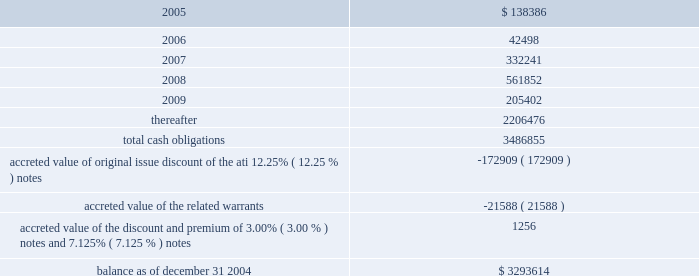American tower corporation and subsidiaries notes to consolidated financial statements 2014 ( continued ) other debt repurchases 2014during the year ended december 31 , 2004 , in addition to the redemptions discussed above , the company repurchased in privately negotiated transactions an aggregate of $ 309.7 million face amount of its ati 12.25% ( 12.25 % ) notes ( $ 179.4 million accreted value , net of $ 14.7 million fair value allocated to warrants ) for approximately $ 230.9 million in cash ; repurchased $ 112.1 million principal amount of its 93 20448% ( 20448 % ) notes for $ 118.9 million in cash ; and repurchased $ 73.7 million principal amount of its 5.0% ( 5.0 % ) notes for approximately $ 73.3 million in cash .
As a consequence of these transactions , the company recorded an aggregate charge of $ 66.4 million related to the write-off of deferred financing fees and amounts paid in excess of carrying value .
Such loss is reflected in loss on retirement of long-term obligations in the accompanying condensed consolidated statement of operations for the year ended december 31 , 2004 .
2.25% ( 2.25 % ) convertible notes repurchases 2014during the year ended december 31 , 2003 , the company repurchased an aggregate of $ 215.0 million accreted value ( $ 269.8 million face value ) of its 2.25% ( 2.25 % ) notes in exchange for an aggregate of 8415984 shares of class a common stock and $ 166.4 million in cash , including $ 84.2 million accreted value ( $ 104.9 million face amount ) of 2.25% ( 2.25 % ) notes repurchased in the company 2019s cash tender offer in october 2003 .
The shares issued to noteholders included an aggregate of 6440636 shares of class a common stock issued to such holders in addition to the amounts issuable upon conversion of those notes as provided in the applicable indentures .
The company made these repurchases pursuant to negotiated transactions with a limited number of note holders .
As a consequence of these transactions , the company recorded charges of approximately $ 41.4 million during the year ended december 31 , 2003 , which primarily represent the fair market value of the shares of stock issued to the note holders in excess of the number of shares originally issuable upon conversion of the notes , as well as cash paid in excess of the related debt retired .
These charges are included in loss on retirement of long-term obligations in the accompanying consolidated statement of operations for the year ended december 31 , 2003 .
Capital lease obligations and notes payable 2014the company 2019s capital lease obligations and notes payable approximated $ 60.0 million and $ 58.7 million as of december 31 , 2004 and 2003 , respectively .
These obligations bear interest at rates ranging from 7.9% ( 7.9 % ) to 12.0% ( 12.0 % ) and mature in periods ranging from less than one year to approximately seventy years .
Maturities 2014as of december 31 , 2004 , aggregate principal payments of long-term debt , including capital leases , for the next five years and thereafter are estimated to be ( in thousands ) : year ending december 31 .
The holders of the company 2019s 5.0% ( 5.0 % ) notes have the right to require the company to repurchase their notes on specified dates prior to the maturity date in 2010 , but the company may pay the purchase price by issuing shares of class a common stock , subject to certain conditions .
Obligations with respect to the right of the holders to put the 5.0% ( 5.0 % ) notes have been included in the table above as if such notes mature the date on which the put rights become exercisable in 2007. .
What percentage of total cash obligations are due in 2005? 
Computations: (138386 / 3486855)
Answer: 0.03969. American tower corporation and subsidiaries notes to consolidated financial statements 2014 ( continued ) other debt repurchases 2014during the year ended december 31 , 2004 , in addition to the redemptions discussed above , the company repurchased in privately negotiated transactions an aggregate of $ 309.7 million face amount of its ati 12.25% ( 12.25 % ) notes ( $ 179.4 million accreted value , net of $ 14.7 million fair value allocated to warrants ) for approximately $ 230.9 million in cash ; repurchased $ 112.1 million principal amount of its 93 20448% ( 20448 % ) notes for $ 118.9 million in cash ; and repurchased $ 73.7 million principal amount of its 5.0% ( 5.0 % ) notes for approximately $ 73.3 million in cash .
As a consequence of these transactions , the company recorded an aggregate charge of $ 66.4 million related to the write-off of deferred financing fees and amounts paid in excess of carrying value .
Such loss is reflected in loss on retirement of long-term obligations in the accompanying condensed consolidated statement of operations for the year ended december 31 , 2004 .
2.25% ( 2.25 % ) convertible notes repurchases 2014during the year ended december 31 , 2003 , the company repurchased an aggregate of $ 215.0 million accreted value ( $ 269.8 million face value ) of its 2.25% ( 2.25 % ) notes in exchange for an aggregate of 8415984 shares of class a common stock and $ 166.4 million in cash , including $ 84.2 million accreted value ( $ 104.9 million face amount ) of 2.25% ( 2.25 % ) notes repurchased in the company 2019s cash tender offer in october 2003 .
The shares issued to noteholders included an aggregate of 6440636 shares of class a common stock issued to such holders in addition to the amounts issuable upon conversion of those notes as provided in the applicable indentures .
The company made these repurchases pursuant to negotiated transactions with a limited number of note holders .
As a consequence of these transactions , the company recorded charges of approximately $ 41.4 million during the year ended december 31 , 2003 , which primarily represent the fair market value of the shares of stock issued to the note holders in excess of the number of shares originally issuable upon conversion of the notes , as well as cash paid in excess of the related debt retired .
These charges are included in loss on retirement of long-term obligations in the accompanying consolidated statement of operations for the year ended december 31 , 2003 .
Capital lease obligations and notes payable 2014the company 2019s capital lease obligations and notes payable approximated $ 60.0 million and $ 58.7 million as of december 31 , 2004 and 2003 , respectively .
These obligations bear interest at rates ranging from 7.9% ( 7.9 % ) to 12.0% ( 12.0 % ) and mature in periods ranging from less than one year to approximately seventy years .
Maturities 2014as of december 31 , 2004 , aggregate principal payments of long-term debt , including capital leases , for the next five years and thereafter are estimated to be ( in thousands ) : year ending december 31 .
The holders of the company 2019s 5.0% ( 5.0 % ) notes have the right to require the company to repurchase their notes on specified dates prior to the maturity date in 2010 , but the company may pay the purchase price by issuing shares of class a common stock , subject to certain conditions .
Obligations with respect to the right of the holders to put the 5.0% ( 5.0 % ) notes have been included in the table above as if such notes mature the date on which the put rights become exercisable in 2007. .
What percentage of total cash obligations are due after 2009? 
Computations: (2206476 / 3486855)
Answer: 0.6328. 